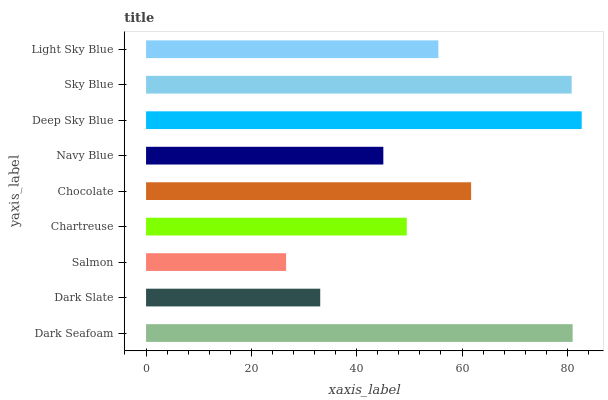Is Salmon the minimum?
Answer yes or no. Yes. Is Deep Sky Blue the maximum?
Answer yes or no. Yes. Is Dark Slate the minimum?
Answer yes or no. No. Is Dark Slate the maximum?
Answer yes or no. No. Is Dark Seafoam greater than Dark Slate?
Answer yes or no. Yes. Is Dark Slate less than Dark Seafoam?
Answer yes or no. Yes. Is Dark Slate greater than Dark Seafoam?
Answer yes or no. No. Is Dark Seafoam less than Dark Slate?
Answer yes or no. No. Is Light Sky Blue the high median?
Answer yes or no. Yes. Is Light Sky Blue the low median?
Answer yes or no. Yes. Is Chartreuse the high median?
Answer yes or no. No. Is Chocolate the low median?
Answer yes or no. No. 